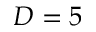<formula> <loc_0><loc_0><loc_500><loc_500>D = 5</formula> 